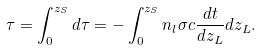<formula> <loc_0><loc_0><loc_500><loc_500>\tau = \int _ { 0 } ^ { z _ { S } } d \tau = - \int _ { 0 } ^ { z _ { S } } n _ { l } \sigma c \frac { d t } { d z _ { L } } d z _ { L } .</formula> 